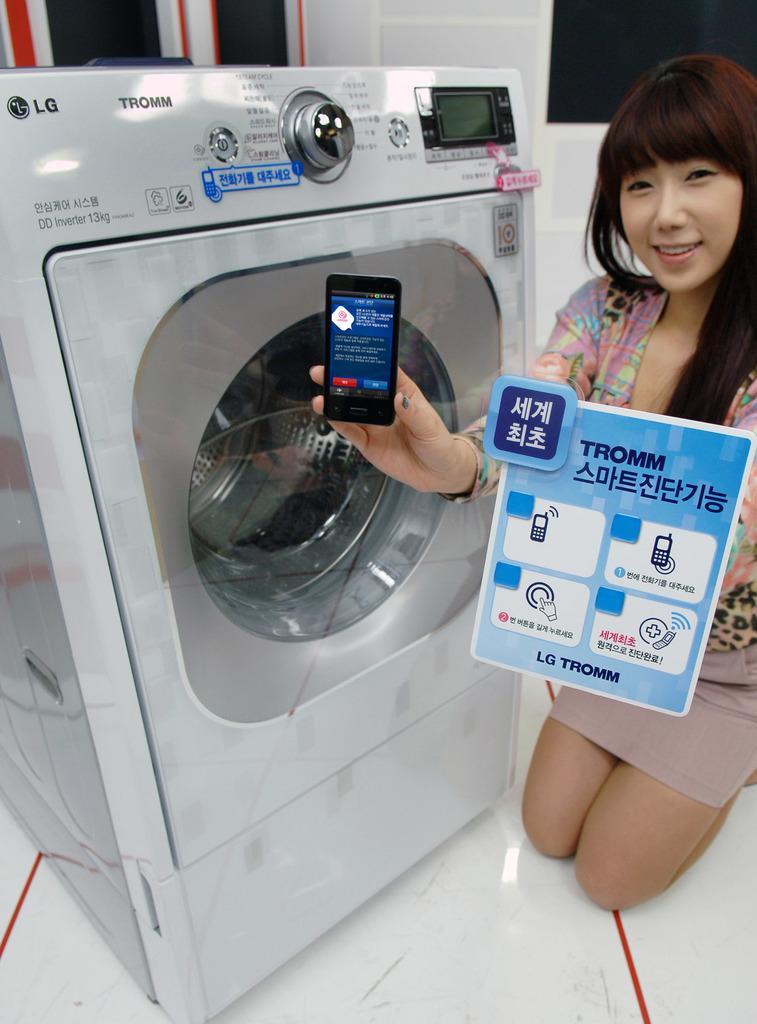Could you give a brief overview of what you see in this image? In this image there is a woman towards the right of the image, she is holding an object, there is a washing machine towards the left of the image, there is text on the washing machine, there is floor towards the bottom of the image, there are objects towards the top of the image, there is a wall towards the top of the image. 